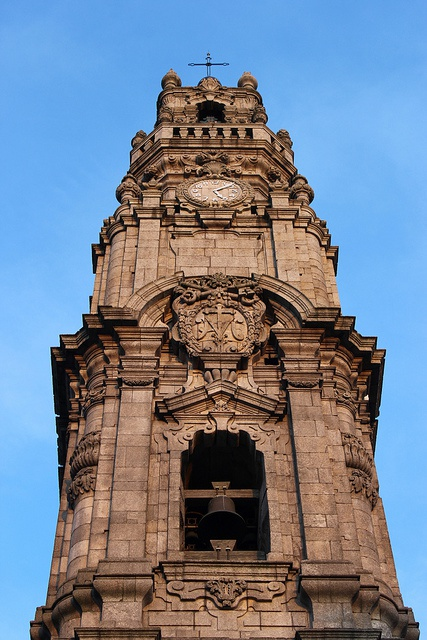Describe the objects in this image and their specific colors. I can see a clock in lightblue, tan, lightgray, and darkgray tones in this image. 